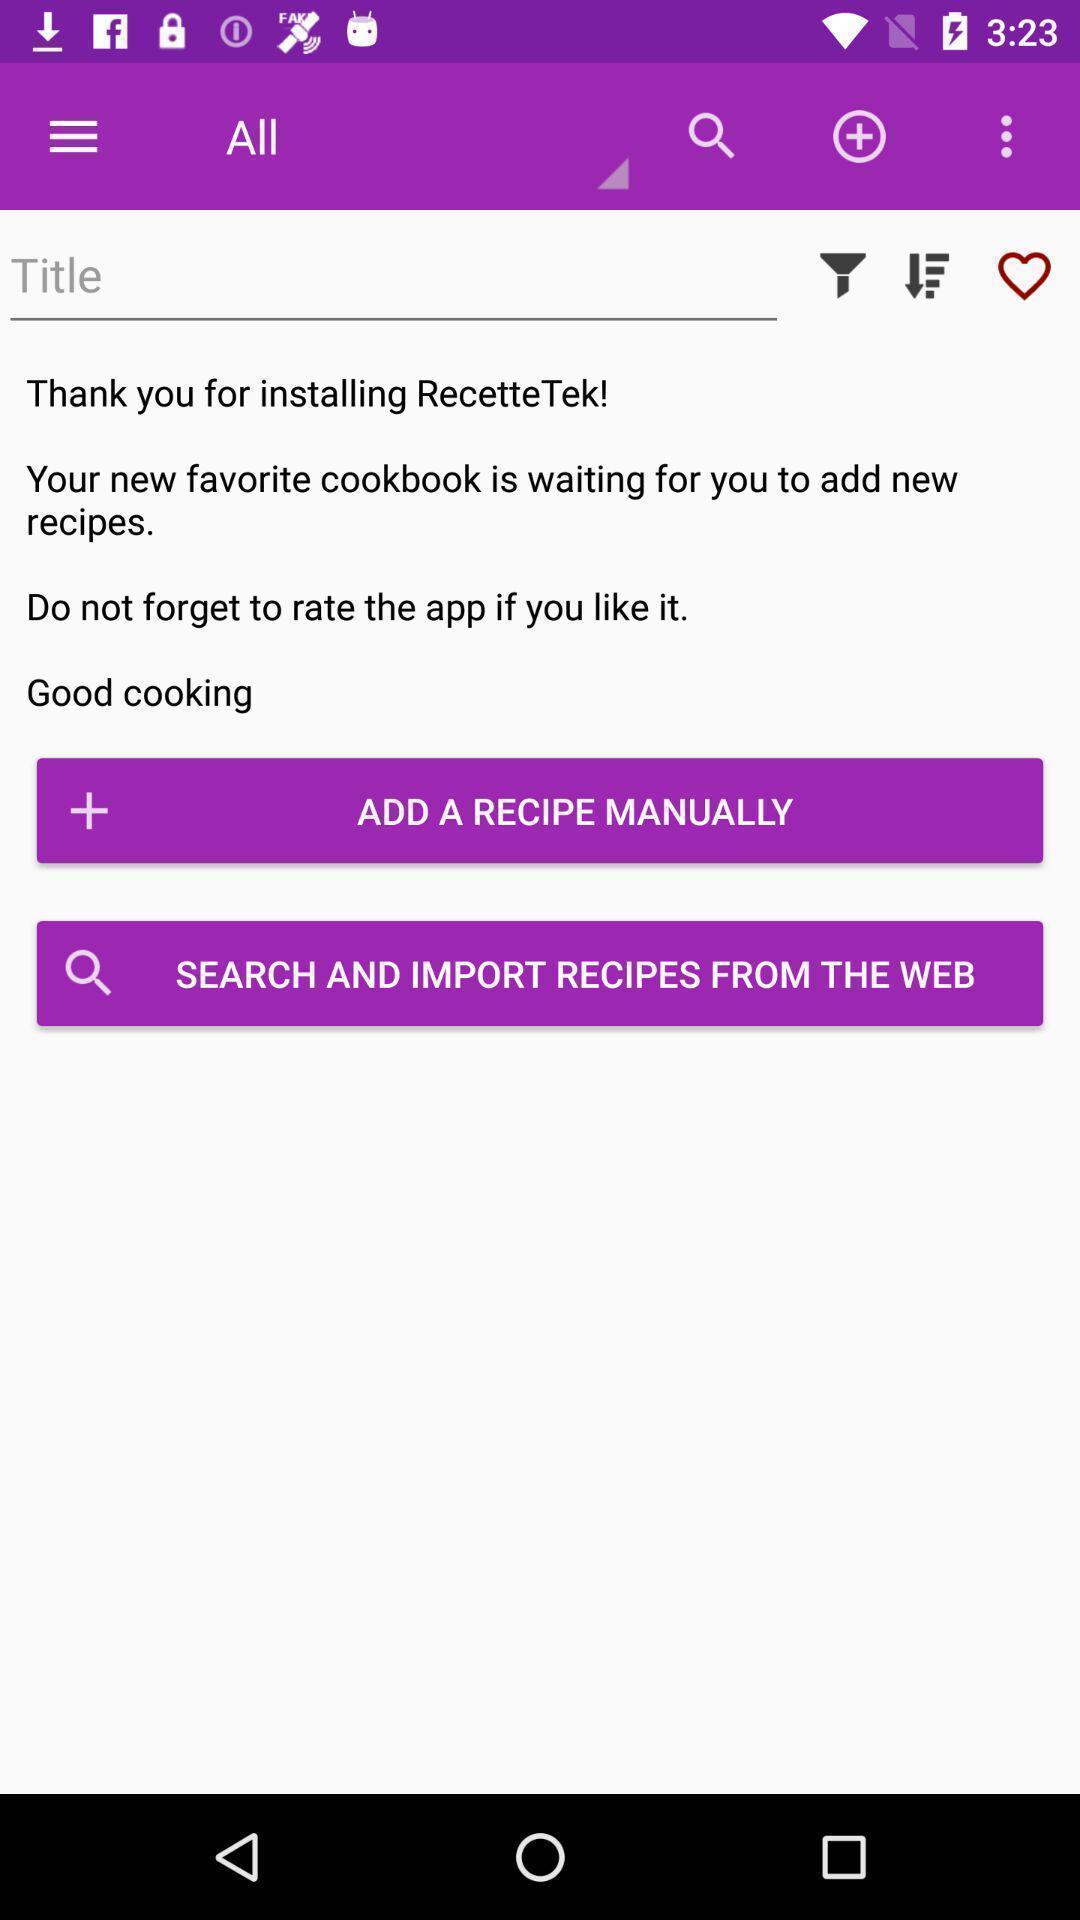Summarize the information in this screenshot. Page with all options of a recipes app. 